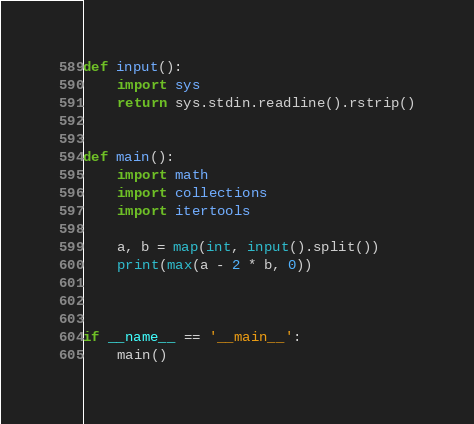<code> <loc_0><loc_0><loc_500><loc_500><_Python_>def input():
    import sys
    return sys.stdin.readline().rstrip()


def main():
    import math
    import collections
    import itertools

    a, b = map(int, input().split())
    print(max(a - 2 * b, 0))



if __name__ == '__main__':
    main()</code> 